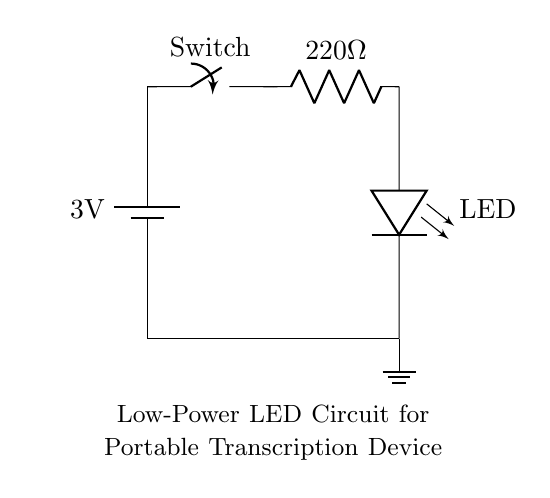What is the voltage rating of the battery in the circuit? The voltage rating is 3 volts, which is indicated next to the battery symbol in the diagram.
Answer: 3 volts What is the resistance value of the resistor in the circuit? The resistance is 220 ohms, which is noted next to the resistor symbol within the circuit.
Answer: 220 ohms What component is used to convert electrical energy into light? The component used for this purpose is the LED, which is labeled in the circuit diagram.
Answer: LED Does the circuit include a switch? Yes, the circuit contains a switch, marked clearly in the circuit, allowing for connectivity control.
Answer: Yes What type of circuit is this primarily used for? This is a low-power circuit designed for a portable transcription device, as referenced in the title.
Answer: Portable transcription device How many major components are there in the circuit? The circuit consists of four major components: a battery, a switch, a resistor, and an LED.
Answer: Four major components What happens to the current when the switch is closed? When the switch is closed, the current flows from the battery through the resistor and LED, illuminating the LED.
Answer: Current flows 